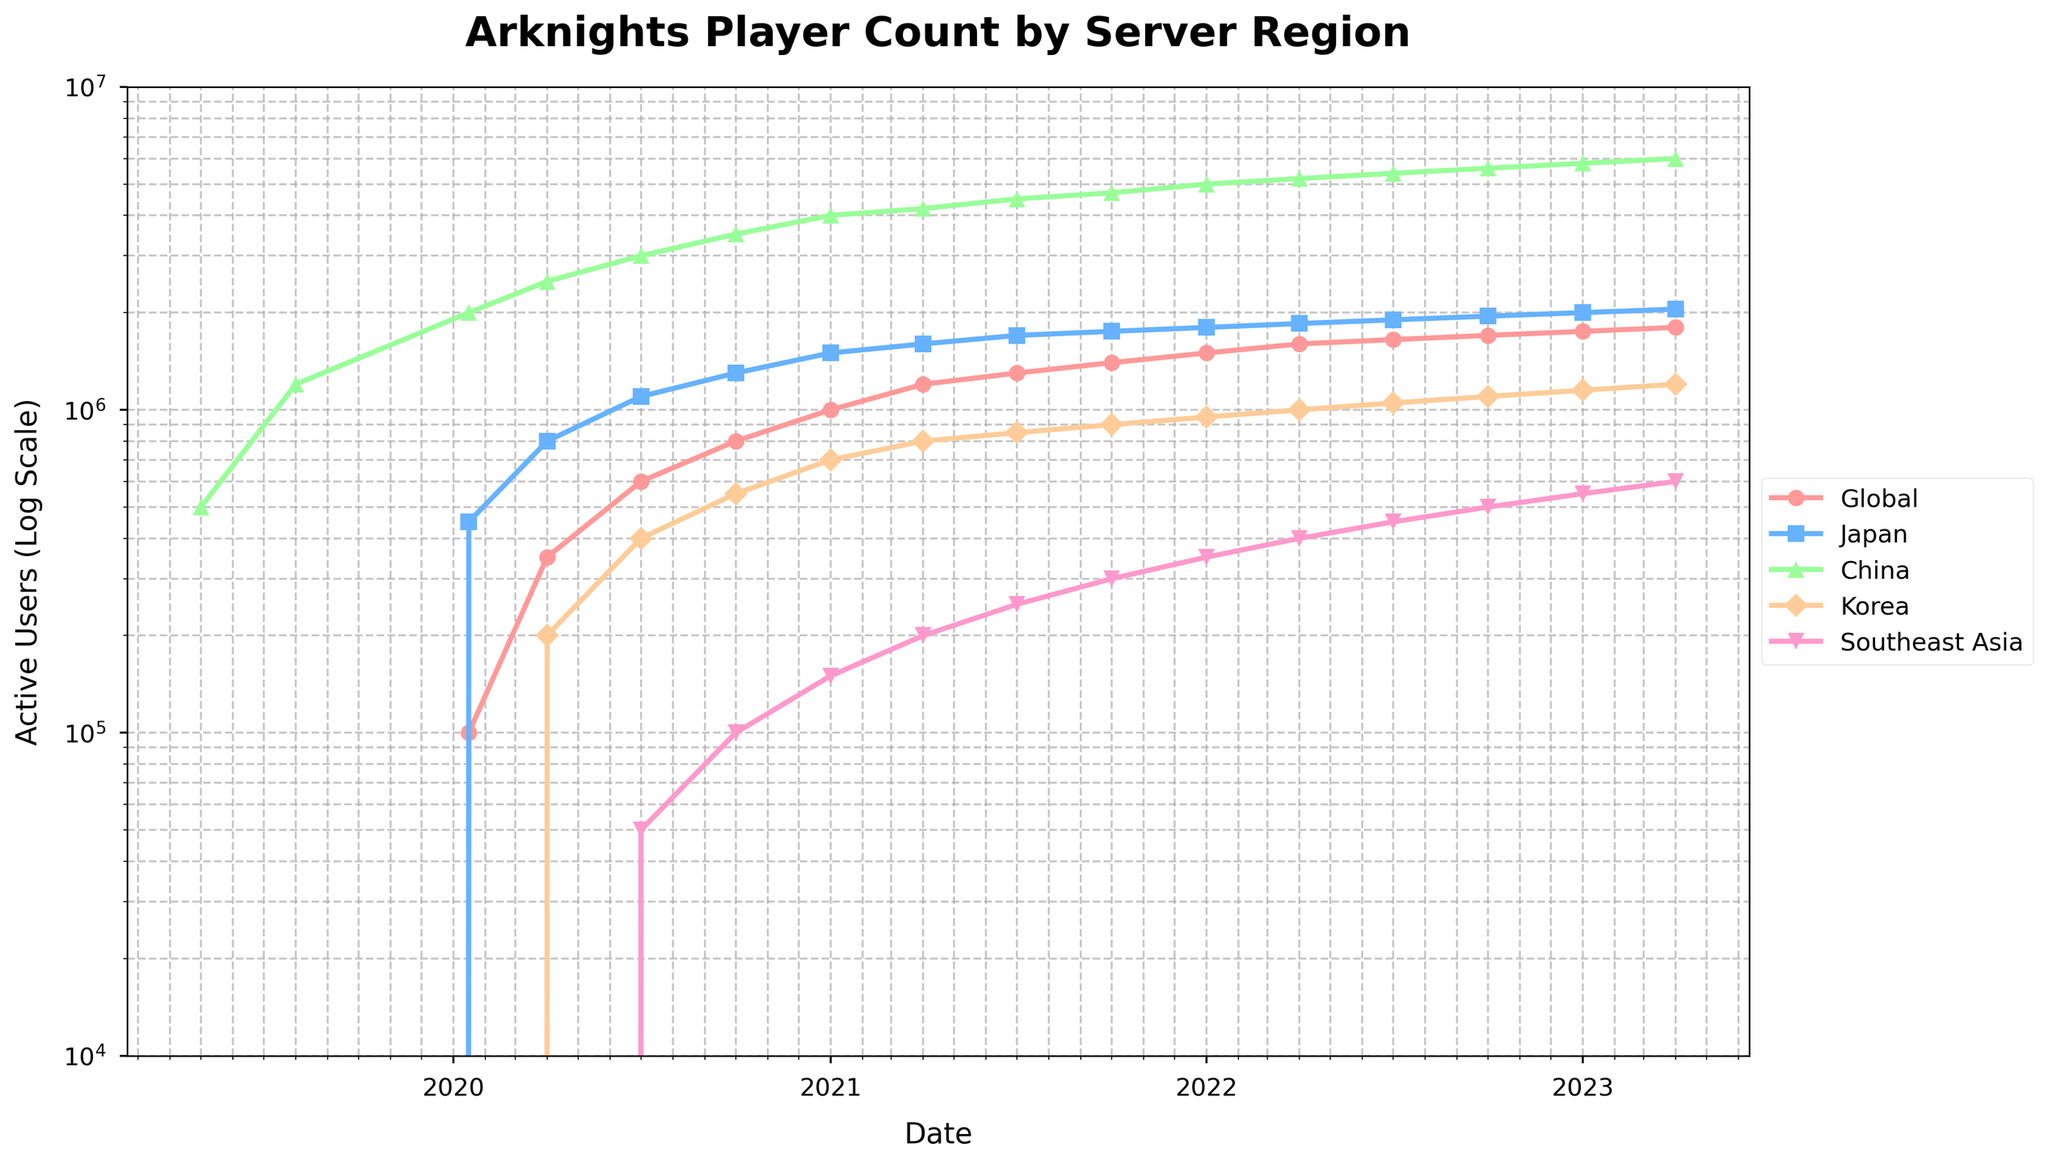What is the overall trend in the active user count for the Global server from 2019 to 2023? The line chart shows an increasing trend in active users for the Global server. Starting from 100,000 users in January 2020, the count reaches 1,800,000 by April 2023.
Answer: Increasing trend Which server had the highest number of active users in January 2020, and what was the count? By visual inspection, the China server had the highest number of active users in January 2020, with around 2,000,000 users.
Answer: China, 2,000,000 By what factor did the active user count increase in the Southeast Asia server from July 2020 to April 2023? In July 2020, the Southeast Asia server had 50,000 users, and in April 2023, it had 600,000 users. The factor of increase is 600,000 / 50,000 = 12.
Answer: 12 Between October 2020 and January 2021, which server showed the fastest growth in active users? By how much did it grow? The Global server shows the fastest growth, increasing from 800,000 to 1,000,000 users. The growth is 1,000,000 - 800,000 = 200,000.
Answer: Global, 200,000 Compare the active user counts between the Japan server and the Korea server in July 2021. Which one is higher and by how much? In July 2021, the Japan server had 1,700,000 users, and the Korea server had 850,000 users. The difference is 1,700,000 - 850,000 = 850,000.
Answer: Japan, 850,000 What is the sum of the active users across all servers in January 2023? In January 2023, the counts are: Global: 1,750,000, Japan: 2,000,000, China: 5,800,000, Korea: 1,150,000, Southeast Asia: 550,000. The sum is 1,750,000 + 2,000,000 + 5,800,000 + 1,150,000 + 550,000 = 11,250,000.
Answer: 11,250,000 Between April 2020 and April 2021, by how much did the active user count change for the China server? In April 2020, the China server had 2,500,000 users, and in April 2021, it had 4,200,000 users. The change is 4,200,000 - 2,500,000 = 1,700,000.
Answer: 1,700,000 What color represents the Japan server on the line chart? By inspecting the line chart legend, the Japan server is represented by the color blue.
Answer: Blue 